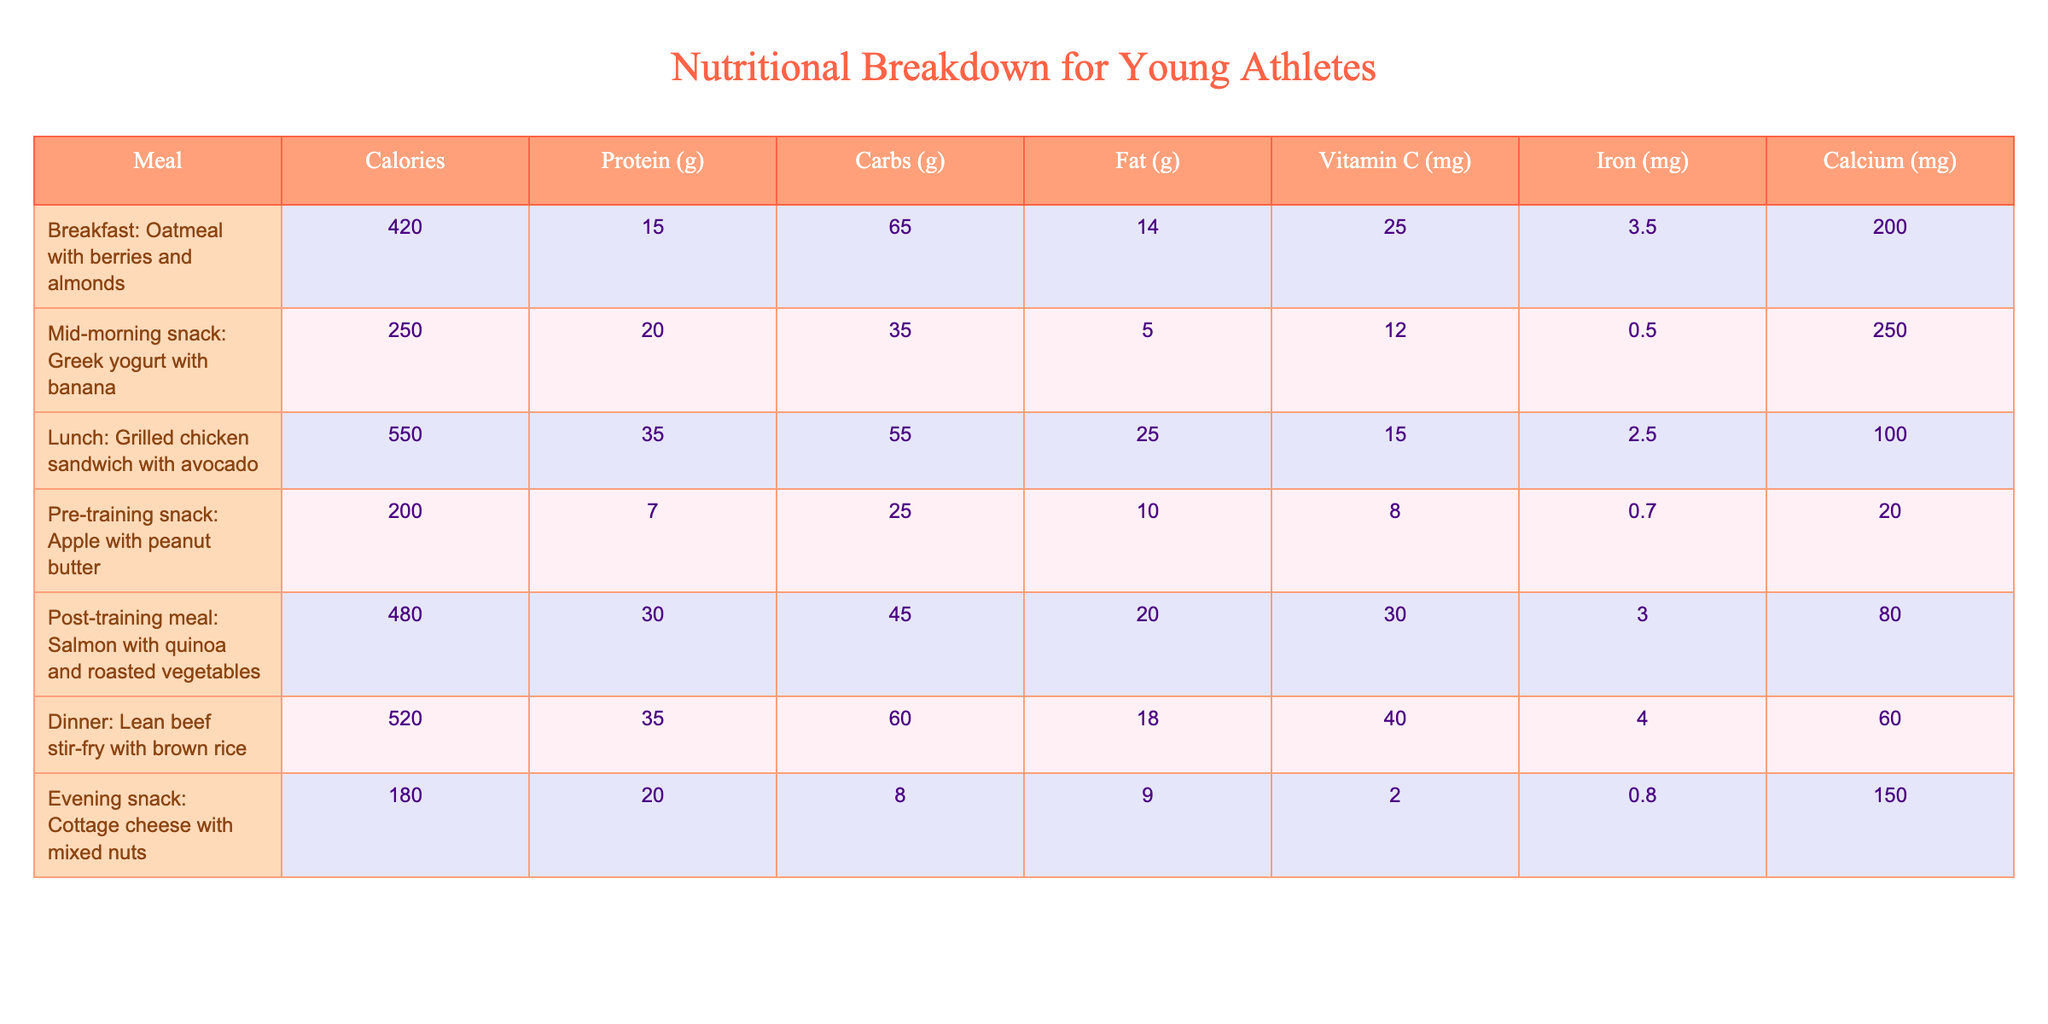What is the calorie content of the lunch meal? According to the table, the lunch meal, which is a grilled chicken sandwich with avocado, has 550 calories listed under the Calories column.
Answer: 550 What meal has the highest protein content? By looking through the protein content of each meal, the lunch (grilled chicken sandwich with avocado) and dinner (lean beef stir-fry with brown rice) both have 35 grams of protein, which is the highest compared to other meals.
Answer: Lunch and Dinner (35 grams) What is the fat content of the evening snack? The evening snack, which is cottage cheese with mixed nuts, has a fat content of 9 grams according to the Fat column in the table.
Answer: 9 grams How many total carbohydrates are there in breakfast and post-training meal combined? The breakfast meal has 65 grams of carbohydrates, and the post-training meal has 45 grams. Adding these together gives: 65 + 45 = 110 grams of carbohydrates combined.
Answer: 110 grams Which meal contains the highest amount of Vitamin C? Upon reviewing the Vitamin C values, the dinner meal (lean beef stir-fry with brown rice) has the highest vitamin C content, at 40 mg.
Answer: Dinner (40 mg) Is the protein content of the pre-training snack higher than that of the mid-morning snack? The pre-training snack has 7 grams of protein, while the mid-morning snack has 20 grams. Since 7 is less than 20, the answer is no.
Answer: No What is the average calcium content across all meals? First, sum the Calcium values: 200 + 250 + 100 + 20 + 80 + 60 + 150 = 860 mg. There are 7 meals, so the average calcium content = 860 / 7 ≈ 122.86 mg.
Answer: ≈ 122.86 mg How much more calories does dinner have compared to breakfast? The dinner meal has 520 calories, and breakfast has 420 calories. The difference is 520 - 420 = 100 calories more in the dinner meal.
Answer: 100 calories What percentage of the total iron content comes from the lunch meal? First, total the iron content: 3.5 + 0.5 + 2.5 + 0.7 + 3 + 4 + 0.8 = 15.0 mg. The lunch meal has 2.5 mg of iron. The percentage is (2.5 / 15.0) * 100 = 16.67%.
Answer: 16.67% Which meal has the lowest number of calories and how many are there? The evening snack has the lowest calories at 180, according to the Calories column in the table.
Answer: 180 calories 